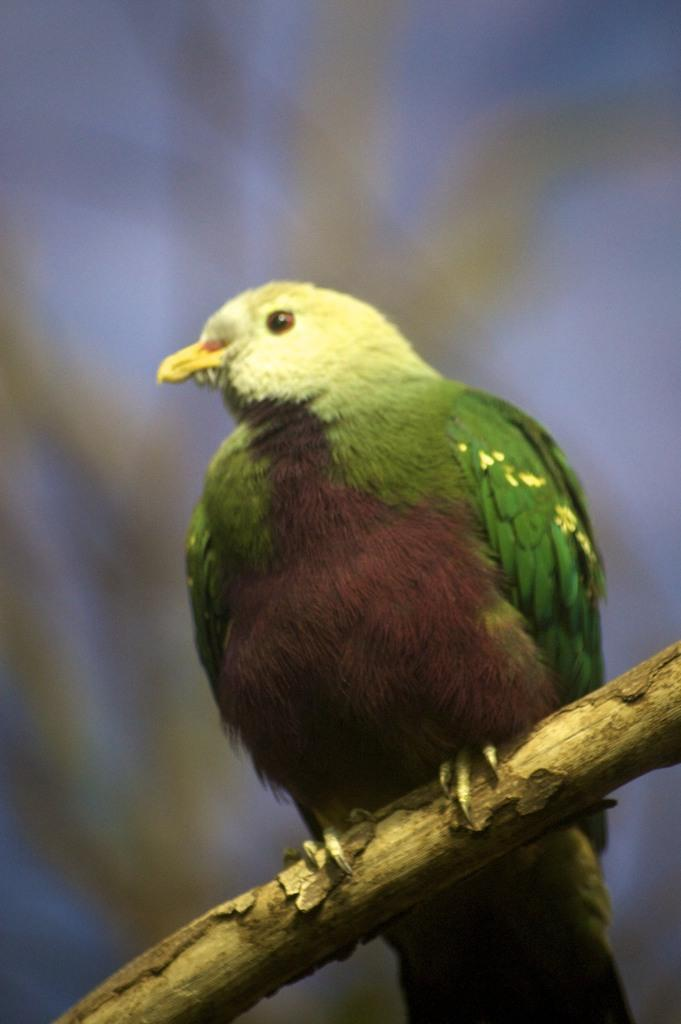What type of animal can be seen in the image? There is a bird in the image. What is the bird standing on? The bird is standing on a wooden trunk. Can you describe the background of the image? The background of the image is blurry. What type of guitar is the bird playing in the image? There is no guitar present in the image; it features a bird standing on a wooden trunk. Can you see any fangs on the bird in the image? Birds do not have fangs, so there are no fangs visible on the bird in the image. 